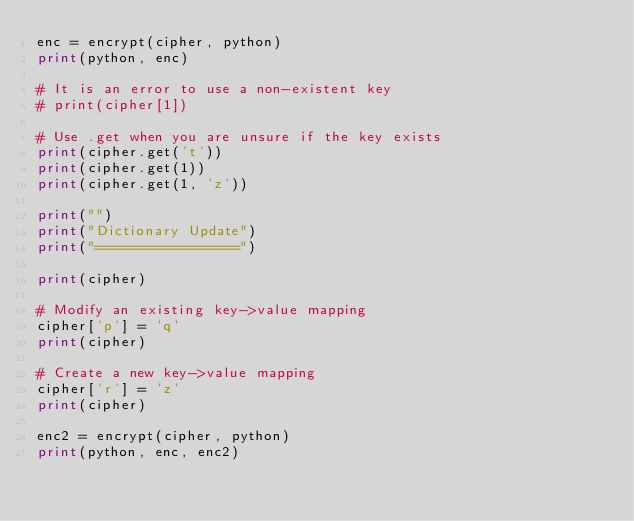<code> <loc_0><loc_0><loc_500><loc_500><_Python_>enc = encrypt(cipher, python)
print(python, enc)

# It is an error to use a non-existent key
# print(cipher[1])

# Use .get when you are unsure if the key exists
print(cipher.get('t'))
print(cipher.get(1))
print(cipher.get(1, 'z'))

print("")
print("Dictionary Update")
print("=================")

print(cipher)

# Modify an existing key->value mapping
cipher['p'] = 'q'
print(cipher)

# Create a new key->value mapping
cipher['r'] = 'z'
print(cipher)

enc2 = encrypt(cipher, python)
print(python, enc, enc2)
</code> 